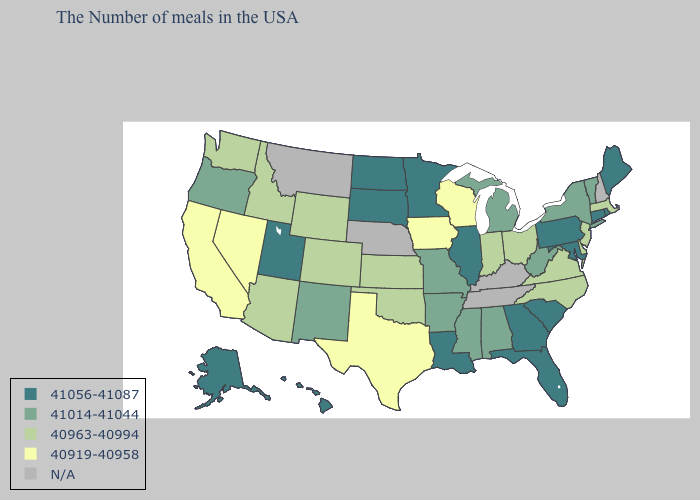What is the value of Tennessee?
Concise answer only. N/A. Which states hav the highest value in the West?
Write a very short answer. Utah, Alaska, Hawaii. Which states hav the highest value in the South?
Write a very short answer. Maryland, South Carolina, Florida, Georgia, Louisiana. Among the states that border Massachusetts , which have the lowest value?
Quick response, please. Vermont, New York. Among the states that border New Mexico , does Texas have the lowest value?
Concise answer only. Yes. What is the value of Kentucky?
Give a very brief answer. N/A. What is the value of Oregon?
Write a very short answer. 41014-41044. Name the states that have a value in the range 40919-40958?
Write a very short answer. Wisconsin, Iowa, Texas, Nevada, California. What is the lowest value in the West?
Short answer required. 40919-40958. How many symbols are there in the legend?
Keep it brief. 5. What is the lowest value in the MidWest?
Give a very brief answer. 40919-40958. Which states have the lowest value in the West?
Keep it brief. Nevada, California. What is the highest value in states that border Nebraska?
Give a very brief answer. 41056-41087. What is the value of Louisiana?
Give a very brief answer. 41056-41087. 